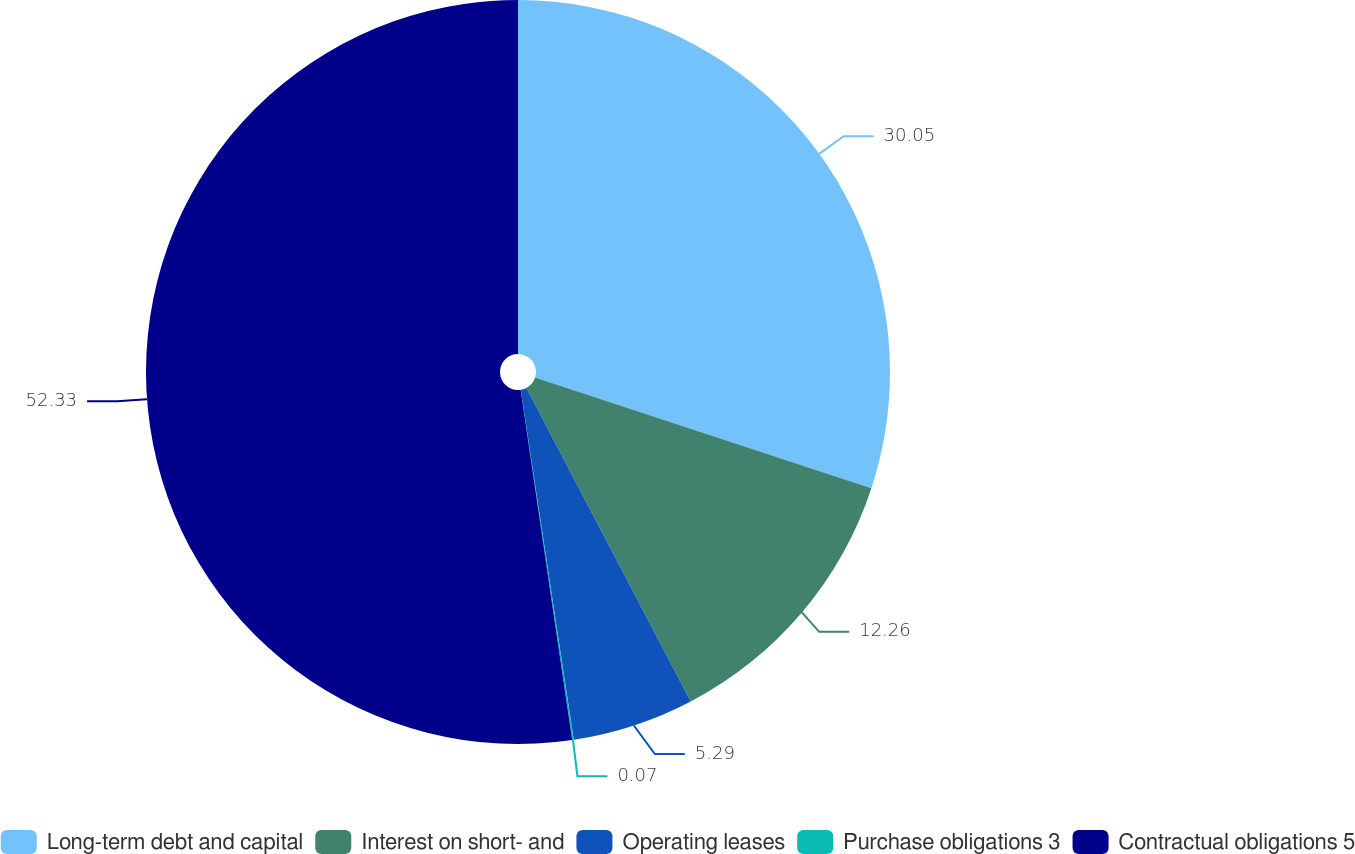<chart> <loc_0><loc_0><loc_500><loc_500><pie_chart><fcel>Long-term debt and capital<fcel>Interest on short- and<fcel>Operating leases<fcel>Purchase obligations 3<fcel>Contractual obligations 5<nl><fcel>30.05%<fcel>12.26%<fcel>5.29%<fcel>0.07%<fcel>52.32%<nl></chart> 